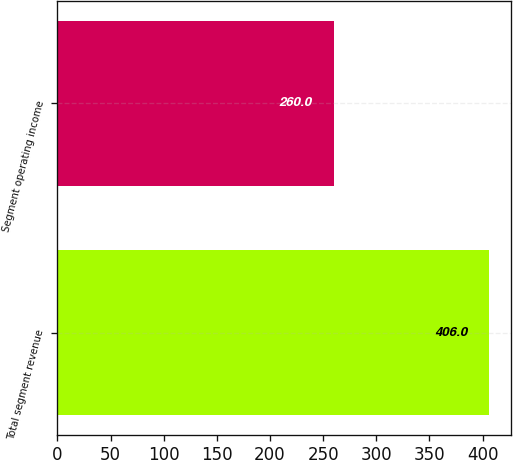Convert chart. <chart><loc_0><loc_0><loc_500><loc_500><bar_chart><fcel>Total segment revenue<fcel>Segment operating income<nl><fcel>406<fcel>260<nl></chart> 